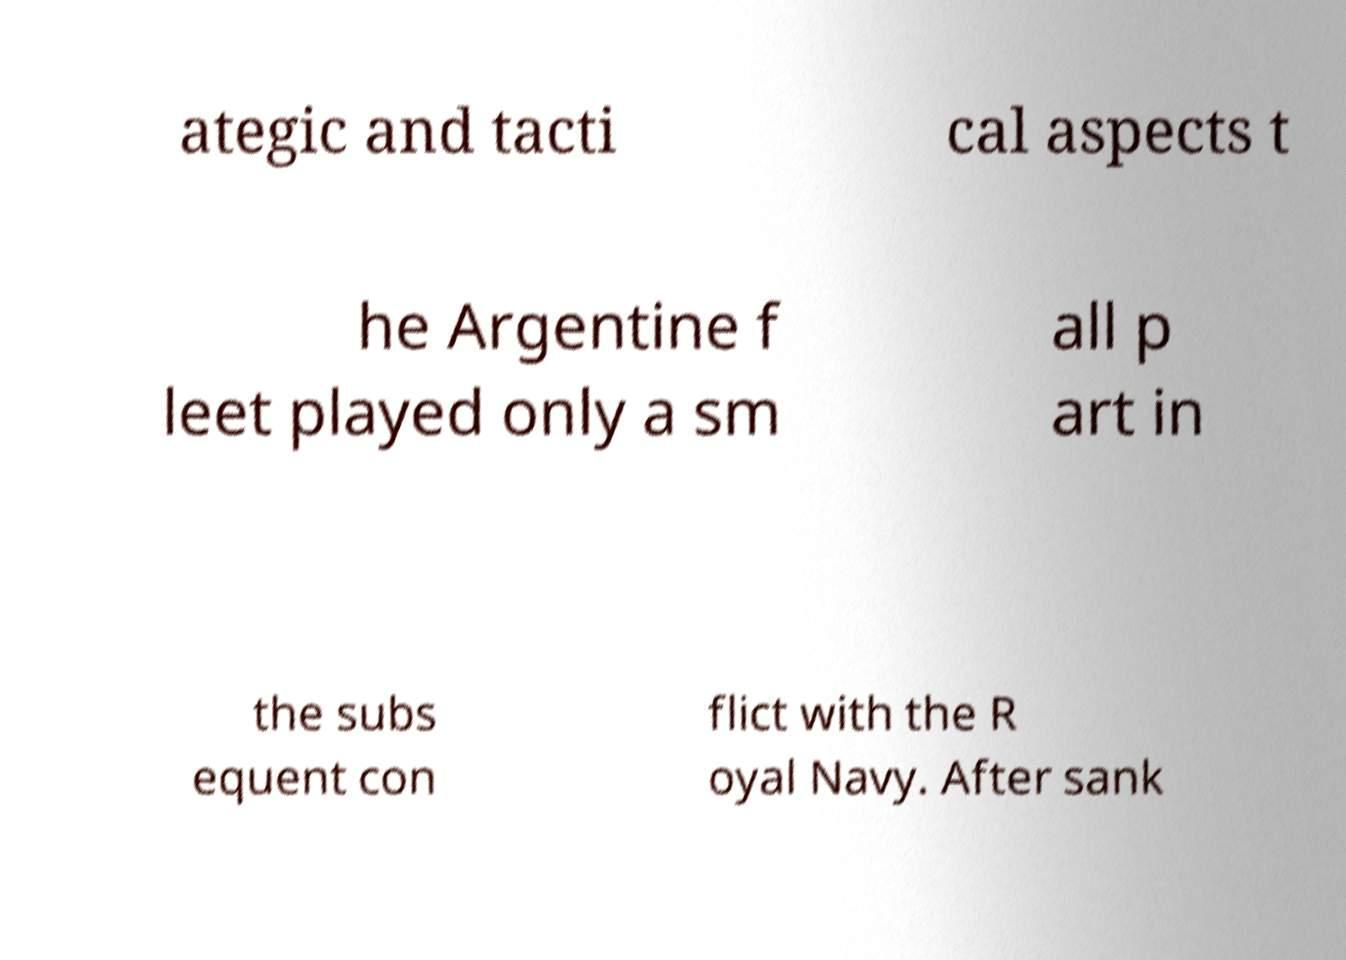Could you assist in decoding the text presented in this image and type it out clearly? ategic and tacti cal aspects t he Argentine f leet played only a sm all p art in the subs equent con flict with the R oyal Navy. After sank 